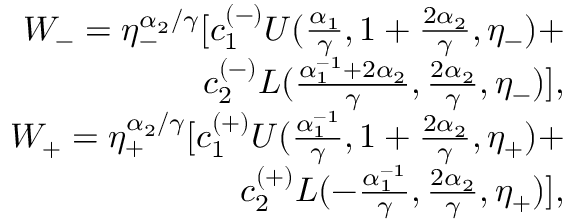Convert formula to latex. <formula><loc_0><loc_0><loc_500><loc_500>\begin{array} { r l r } & { W _ { - } = \eta _ { - } ^ { \alpha _ { 2 } / \gamma } [ c _ { 1 } ^ { ( - ) } U ( \frac { \alpha _ { 1 } } { \gamma } , 1 + \frac { 2 \alpha _ { 2 } } { \gamma } , \eta _ { - } ) + } \\ & { c _ { 2 } ^ { ( - ) } L ( \frac { \alpha _ { 1 } ^ { - 1 } + 2 \alpha _ { 2 } } { \gamma } , \frac { 2 \alpha _ { 2 } } { \gamma } , \eta _ { - } ) ] , } \\ & { W _ { + } = \eta _ { + } ^ { \alpha _ { 2 } / \gamma } [ c _ { 1 } ^ { ( + ) } U ( \frac { \alpha _ { 1 } ^ { - 1 } } { \gamma } , 1 + \frac { 2 \alpha _ { 2 } } { \gamma } , \eta _ { + } ) + } \\ & { c _ { 2 } ^ { ( + ) } L ( - \frac { \alpha _ { 1 } ^ { - 1 } } { \gamma } , \frac { 2 \alpha _ { 2 } } { \gamma } , \eta _ { + } ) ] , } \end{array}</formula> 